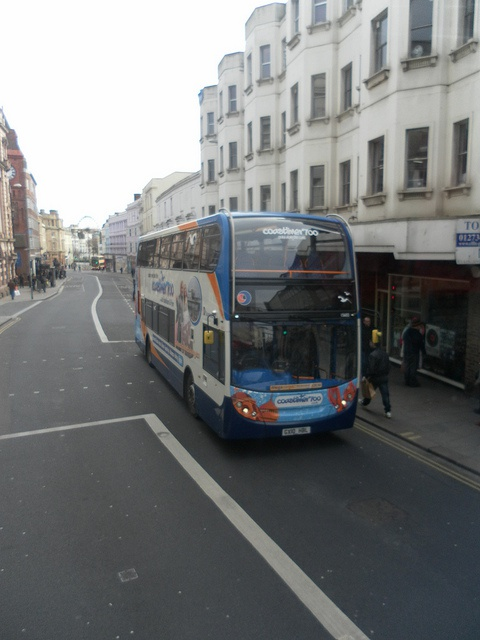Describe the objects in this image and their specific colors. I can see bus in white, black, gray, darkgray, and blue tones, people in white, black, darkgreen, and gray tones, people in black and white tones, people in white, black, brown, and maroon tones, and people in white, gray, blue, and black tones in this image. 